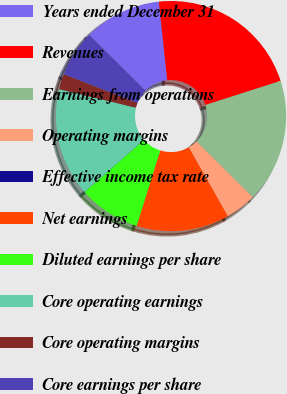Convert chart. <chart><loc_0><loc_0><loc_500><loc_500><pie_chart><fcel>Years ended December 31<fcel>Revenues<fcel>Earnings from operations<fcel>Operating margins<fcel>Effective income tax rate<fcel>Net earnings<fcel>Diluted earnings per share<fcel>Core operating earnings<fcel>Core operating margins<fcel>Core earnings per share<nl><fcel>10.87%<fcel>21.74%<fcel>17.39%<fcel>4.35%<fcel>0.0%<fcel>13.04%<fcel>8.7%<fcel>15.22%<fcel>2.18%<fcel>6.52%<nl></chart> 